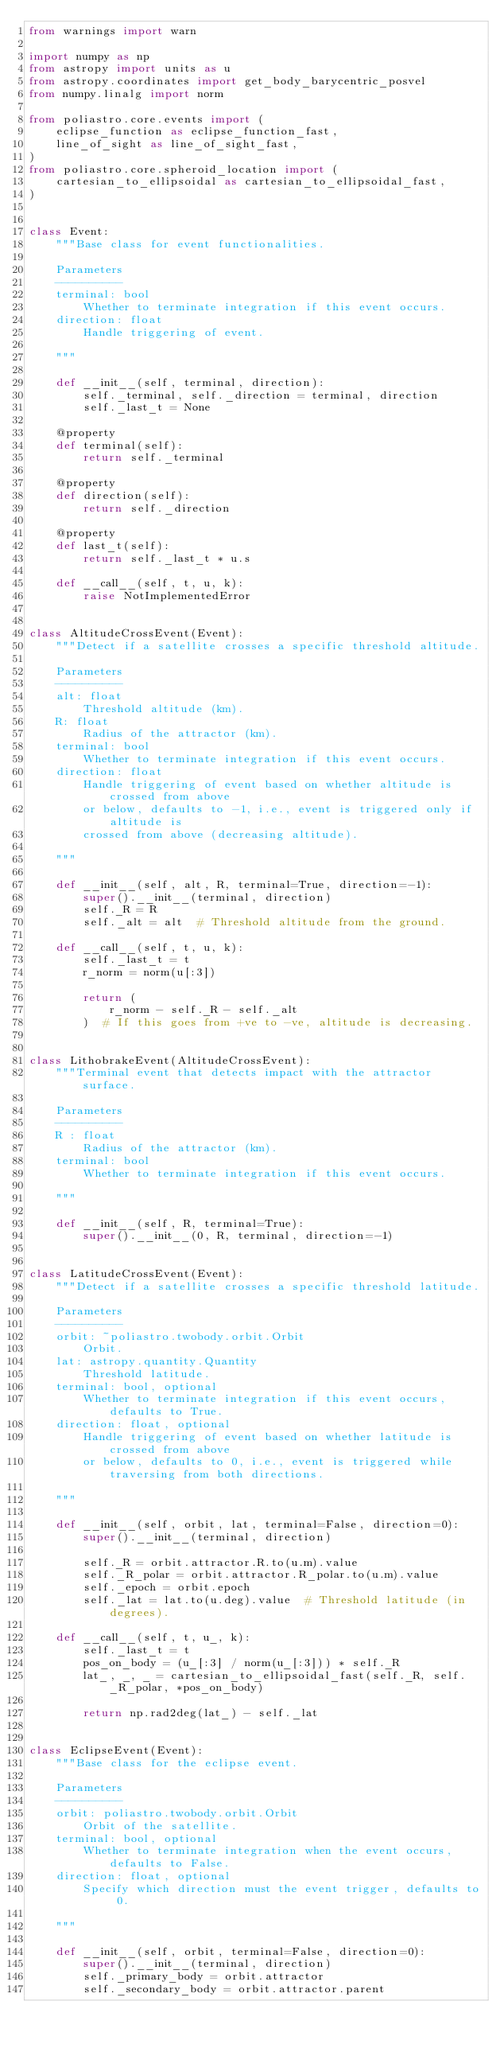Convert code to text. <code><loc_0><loc_0><loc_500><loc_500><_Python_>from warnings import warn

import numpy as np
from astropy import units as u
from astropy.coordinates import get_body_barycentric_posvel
from numpy.linalg import norm

from poliastro.core.events import (
    eclipse_function as eclipse_function_fast,
    line_of_sight as line_of_sight_fast,
)
from poliastro.core.spheroid_location import (
    cartesian_to_ellipsoidal as cartesian_to_ellipsoidal_fast,
)


class Event:
    """Base class for event functionalities.

    Parameters
    ----------
    terminal: bool
        Whether to terminate integration if this event occurs.
    direction: float
        Handle triggering of event.

    """

    def __init__(self, terminal, direction):
        self._terminal, self._direction = terminal, direction
        self._last_t = None

    @property
    def terminal(self):
        return self._terminal

    @property
    def direction(self):
        return self._direction

    @property
    def last_t(self):
        return self._last_t * u.s

    def __call__(self, t, u, k):
        raise NotImplementedError


class AltitudeCrossEvent(Event):
    """Detect if a satellite crosses a specific threshold altitude.

    Parameters
    ----------
    alt: float
        Threshold altitude (km).
    R: float
        Radius of the attractor (km).
    terminal: bool
        Whether to terminate integration if this event occurs.
    direction: float
        Handle triggering of event based on whether altitude is crossed from above
        or below, defaults to -1, i.e., event is triggered only if altitude is
        crossed from above (decreasing altitude).

    """

    def __init__(self, alt, R, terminal=True, direction=-1):
        super().__init__(terminal, direction)
        self._R = R
        self._alt = alt  # Threshold altitude from the ground.

    def __call__(self, t, u, k):
        self._last_t = t
        r_norm = norm(u[:3])

        return (
            r_norm - self._R - self._alt
        )  # If this goes from +ve to -ve, altitude is decreasing.


class LithobrakeEvent(AltitudeCrossEvent):
    """Terminal event that detects impact with the attractor surface.

    Parameters
    ----------
    R : float
        Radius of the attractor (km).
    terminal: bool
        Whether to terminate integration if this event occurs.

    """

    def __init__(self, R, terminal=True):
        super().__init__(0, R, terminal, direction=-1)


class LatitudeCrossEvent(Event):
    """Detect if a satellite crosses a specific threshold latitude.

    Parameters
    ----------
    orbit: ~poliastro.twobody.orbit.Orbit
        Orbit.
    lat: astropy.quantity.Quantity
        Threshold latitude.
    terminal: bool, optional
        Whether to terminate integration if this event occurs, defaults to True.
    direction: float, optional
        Handle triggering of event based on whether latitude is crossed from above
        or below, defaults to 0, i.e., event is triggered while traversing from both directions.

    """

    def __init__(self, orbit, lat, terminal=False, direction=0):
        super().__init__(terminal, direction)

        self._R = orbit.attractor.R.to(u.m).value
        self._R_polar = orbit.attractor.R_polar.to(u.m).value
        self._epoch = orbit.epoch
        self._lat = lat.to(u.deg).value  # Threshold latitude (in degrees).

    def __call__(self, t, u_, k):
        self._last_t = t
        pos_on_body = (u_[:3] / norm(u_[:3])) * self._R
        lat_, _, _ = cartesian_to_ellipsoidal_fast(self._R, self._R_polar, *pos_on_body)

        return np.rad2deg(lat_) - self._lat


class EclipseEvent(Event):
    """Base class for the eclipse event.

    Parameters
    ----------
    orbit: poliastro.twobody.orbit.Orbit
        Orbit of the satellite.
    terminal: bool, optional
        Whether to terminate integration when the event occurs, defaults to False.
    direction: float, optional
        Specify which direction must the event trigger, defaults to 0.

    """

    def __init__(self, orbit, terminal=False, direction=0):
        super().__init__(terminal, direction)
        self._primary_body = orbit.attractor
        self._secondary_body = orbit.attractor.parent</code> 